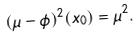<formula> <loc_0><loc_0><loc_500><loc_500>( \mu - \phi ) ^ { 2 } ( x _ { 0 } ) = \mu ^ { 2 } .</formula> 